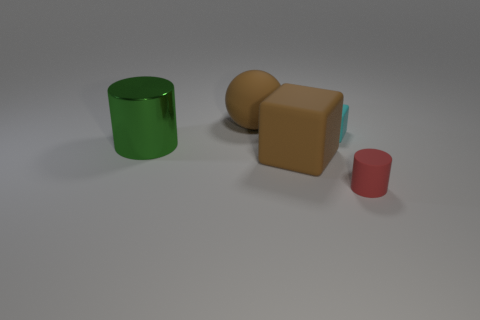Is the large matte sphere the same color as the large block?
Your answer should be compact. Yes. What number of shiny things are either cyan things or large purple things?
Your answer should be compact. 0. There is a large thing that is the same color as the big rubber ball; what material is it?
Ensure brevity in your answer.  Rubber. Is there any other thing that has the same shape as the cyan object?
Give a very brief answer. Yes. What is the material of the block that is in front of the tiny cyan rubber thing?
Your answer should be very brief. Rubber. Do the object behind the tiny cube and the big block have the same material?
Offer a very short reply. Yes. What number of objects are large rubber things or cylinders on the right side of the rubber ball?
Keep it short and to the point. 3. The red matte object that is the same shape as the green thing is what size?
Offer a very short reply. Small. Is there anything else that has the same size as the cyan matte cube?
Offer a terse response. Yes. Are there any tiny matte objects left of the small cylinder?
Your response must be concise. Yes. 